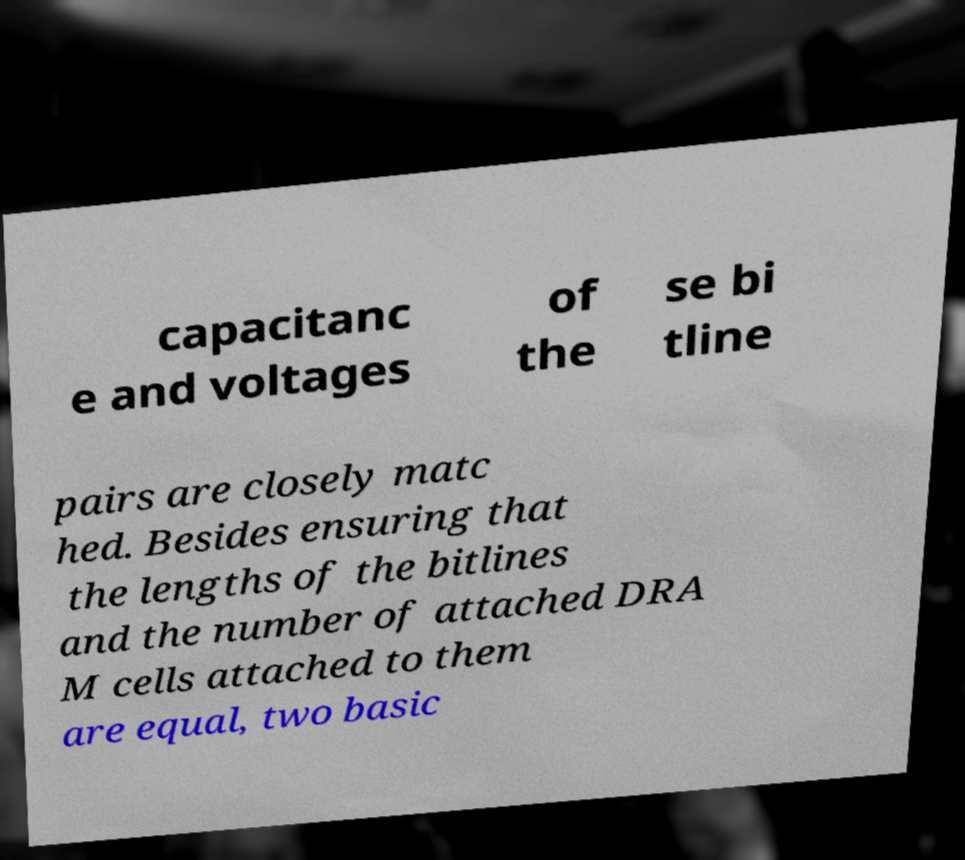I need the written content from this picture converted into text. Can you do that? capacitanc e and voltages of the se bi tline pairs are closely matc hed. Besides ensuring that the lengths of the bitlines and the number of attached DRA M cells attached to them are equal, two basic 